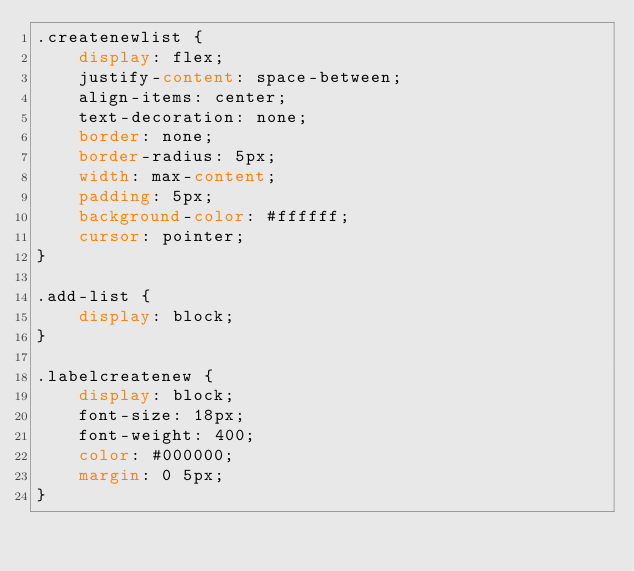Convert code to text. <code><loc_0><loc_0><loc_500><loc_500><_CSS_>.createnewlist {
    display: flex;
    justify-content: space-between;
    align-items: center;
    text-decoration: none;
    border: none;
    border-radius: 5px;
    width: max-content;
    padding: 5px;
    background-color: #ffffff;
    cursor: pointer;
}

.add-list {
    display: block;
}

.labelcreatenew {
    display: block;
    font-size: 18px;
    font-weight: 400;
    color: #000000;
    margin: 0 5px;
}</code> 